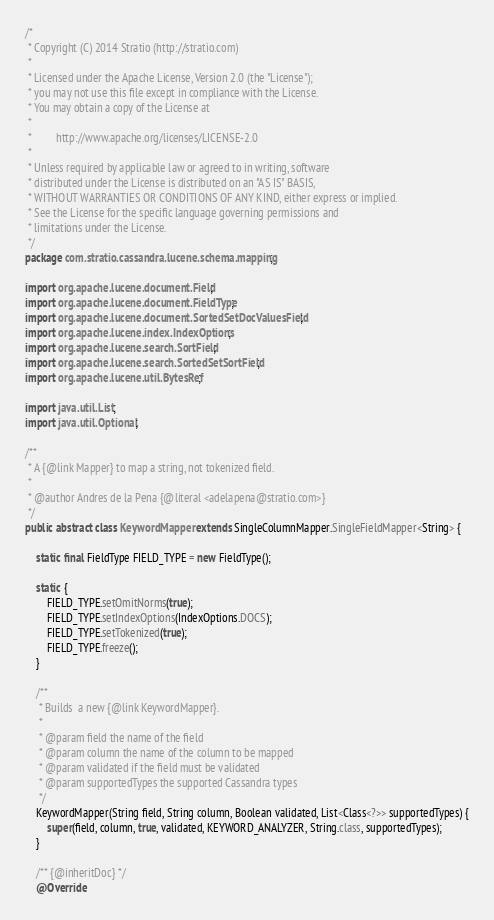Convert code to text. <code><loc_0><loc_0><loc_500><loc_500><_Java_>/*
 * Copyright (C) 2014 Stratio (http://stratio.com)
 *
 * Licensed under the Apache License, Version 2.0 (the "License");
 * you may not use this file except in compliance with the License.
 * You may obtain a copy of the License at
 *
 *         http://www.apache.org/licenses/LICENSE-2.0
 *
 * Unless required by applicable law or agreed to in writing, software
 * distributed under the License is distributed on an "AS IS" BASIS,
 * WITHOUT WARRANTIES OR CONDITIONS OF ANY KIND, either express or implied.
 * See the License for the specific language governing permissions and
 * limitations under the License.
 */
package com.stratio.cassandra.lucene.schema.mapping;

import org.apache.lucene.document.Field;
import org.apache.lucene.document.FieldType;
import org.apache.lucene.document.SortedSetDocValuesField;
import org.apache.lucene.index.IndexOptions;
import org.apache.lucene.search.SortField;
import org.apache.lucene.search.SortedSetSortField;
import org.apache.lucene.util.BytesRef;

import java.util.List;
import java.util.Optional;

/**
 * A {@link Mapper} to map a string, not tokenized field.
 *
 * @author Andres de la Pena {@literal <adelapena@stratio.com>}
 */
public abstract class KeywordMapper extends SingleColumnMapper.SingleFieldMapper<String> {

    static final FieldType FIELD_TYPE = new FieldType();

    static {
        FIELD_TYPE.setOmitNorms(true);
        FIELD_TYPE.setIndexOptions(IndexOptions.DOCS);
        FIELD_TYPE.setTokenized(true);
        FIELD_TYPE.freeze();
    }

    /**
     * Builds  a new {@link KeywordMapper}.
     *
     * @param field the name of the field
     * @param column the name of the column to be mapped
     * @param validated if the field must be validated
     * @param supportedTypes the supported Cassandra types
     */
    KeywordMapper(String field, String column, Boolean validated, List<Class<?>> supportedTypes) {
        super(field, column, true, validated, KEYWORD_ANALYZER, String.class, supportedTypes);
    }

    /** {@inheritDoc} */
    @Override</code> 